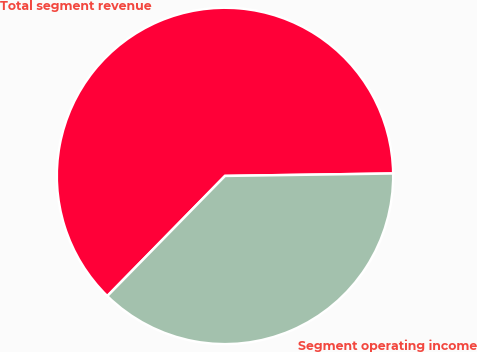Convert chart to OTSL. <chart><loc_0><loc_0><loc_500><loc_500><pie_chart><fcel>Total segment revenue<fcel>Segment operating income<nl><fcel>62.43%<fcel>37.57%<nl></chart> 